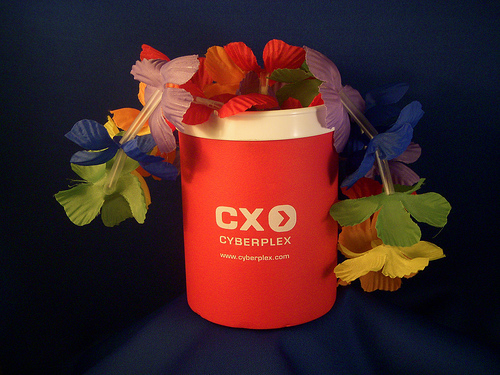<image>
Can you confirm if the cup is next to the flowers? No. The cup is not positioned next to the flowers. They are located in different areas of the scene. Where is the flower in relation to the cup? Is it in front of the cup? No. The flower is not in front of the cup. The spatial positioning shows a different relationship between these objects. 